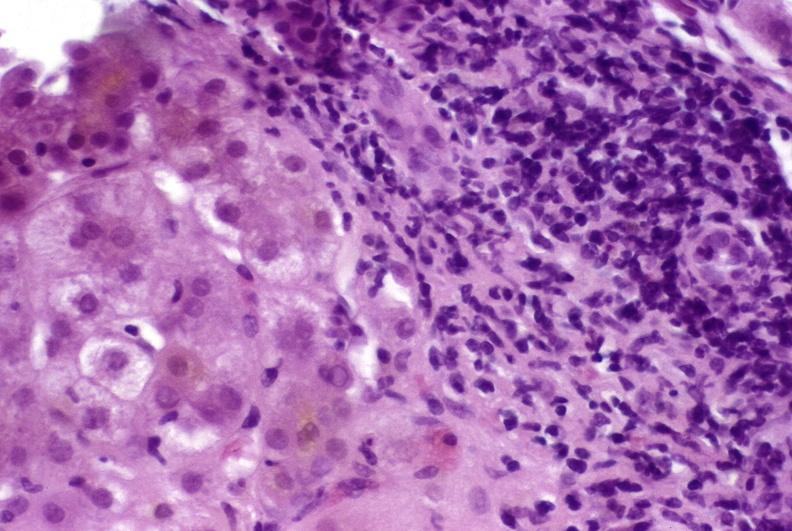what is present?
Answer the question using a single word or phrase. Hepatobiliary 